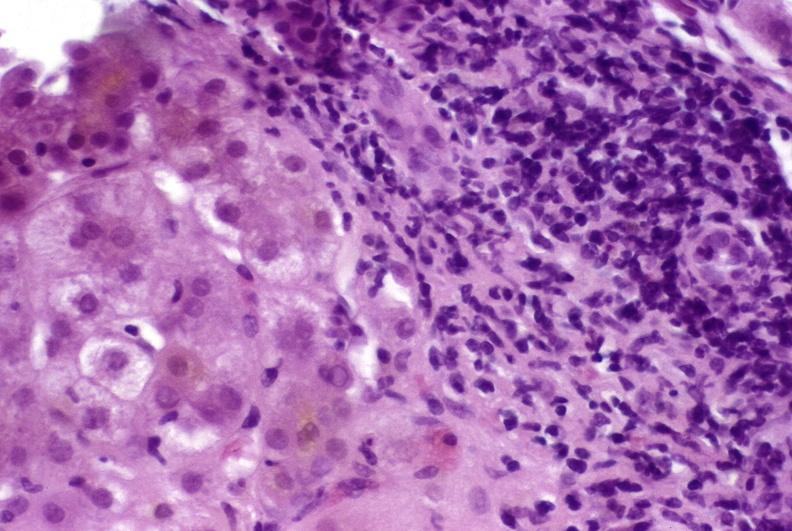what is present?
Answer the question using a single word or phrase. Hepatobiliary 